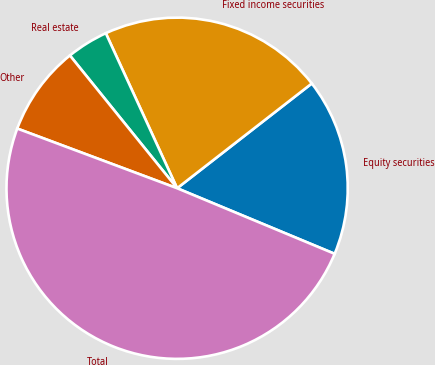Convert chart to OTSL. <chart><loc_0><loc_0><loc_500><loc_500><pie_chart><fcel>Equity securities<fcel>Fixed income securities<fcel>Real estate<fcel>Other<fcel>Total<nl><fcel>16.8%<fcel>21.34%<fcel>3.95%<fcel>8.5%<fcel>49.41%<nl></chart> 